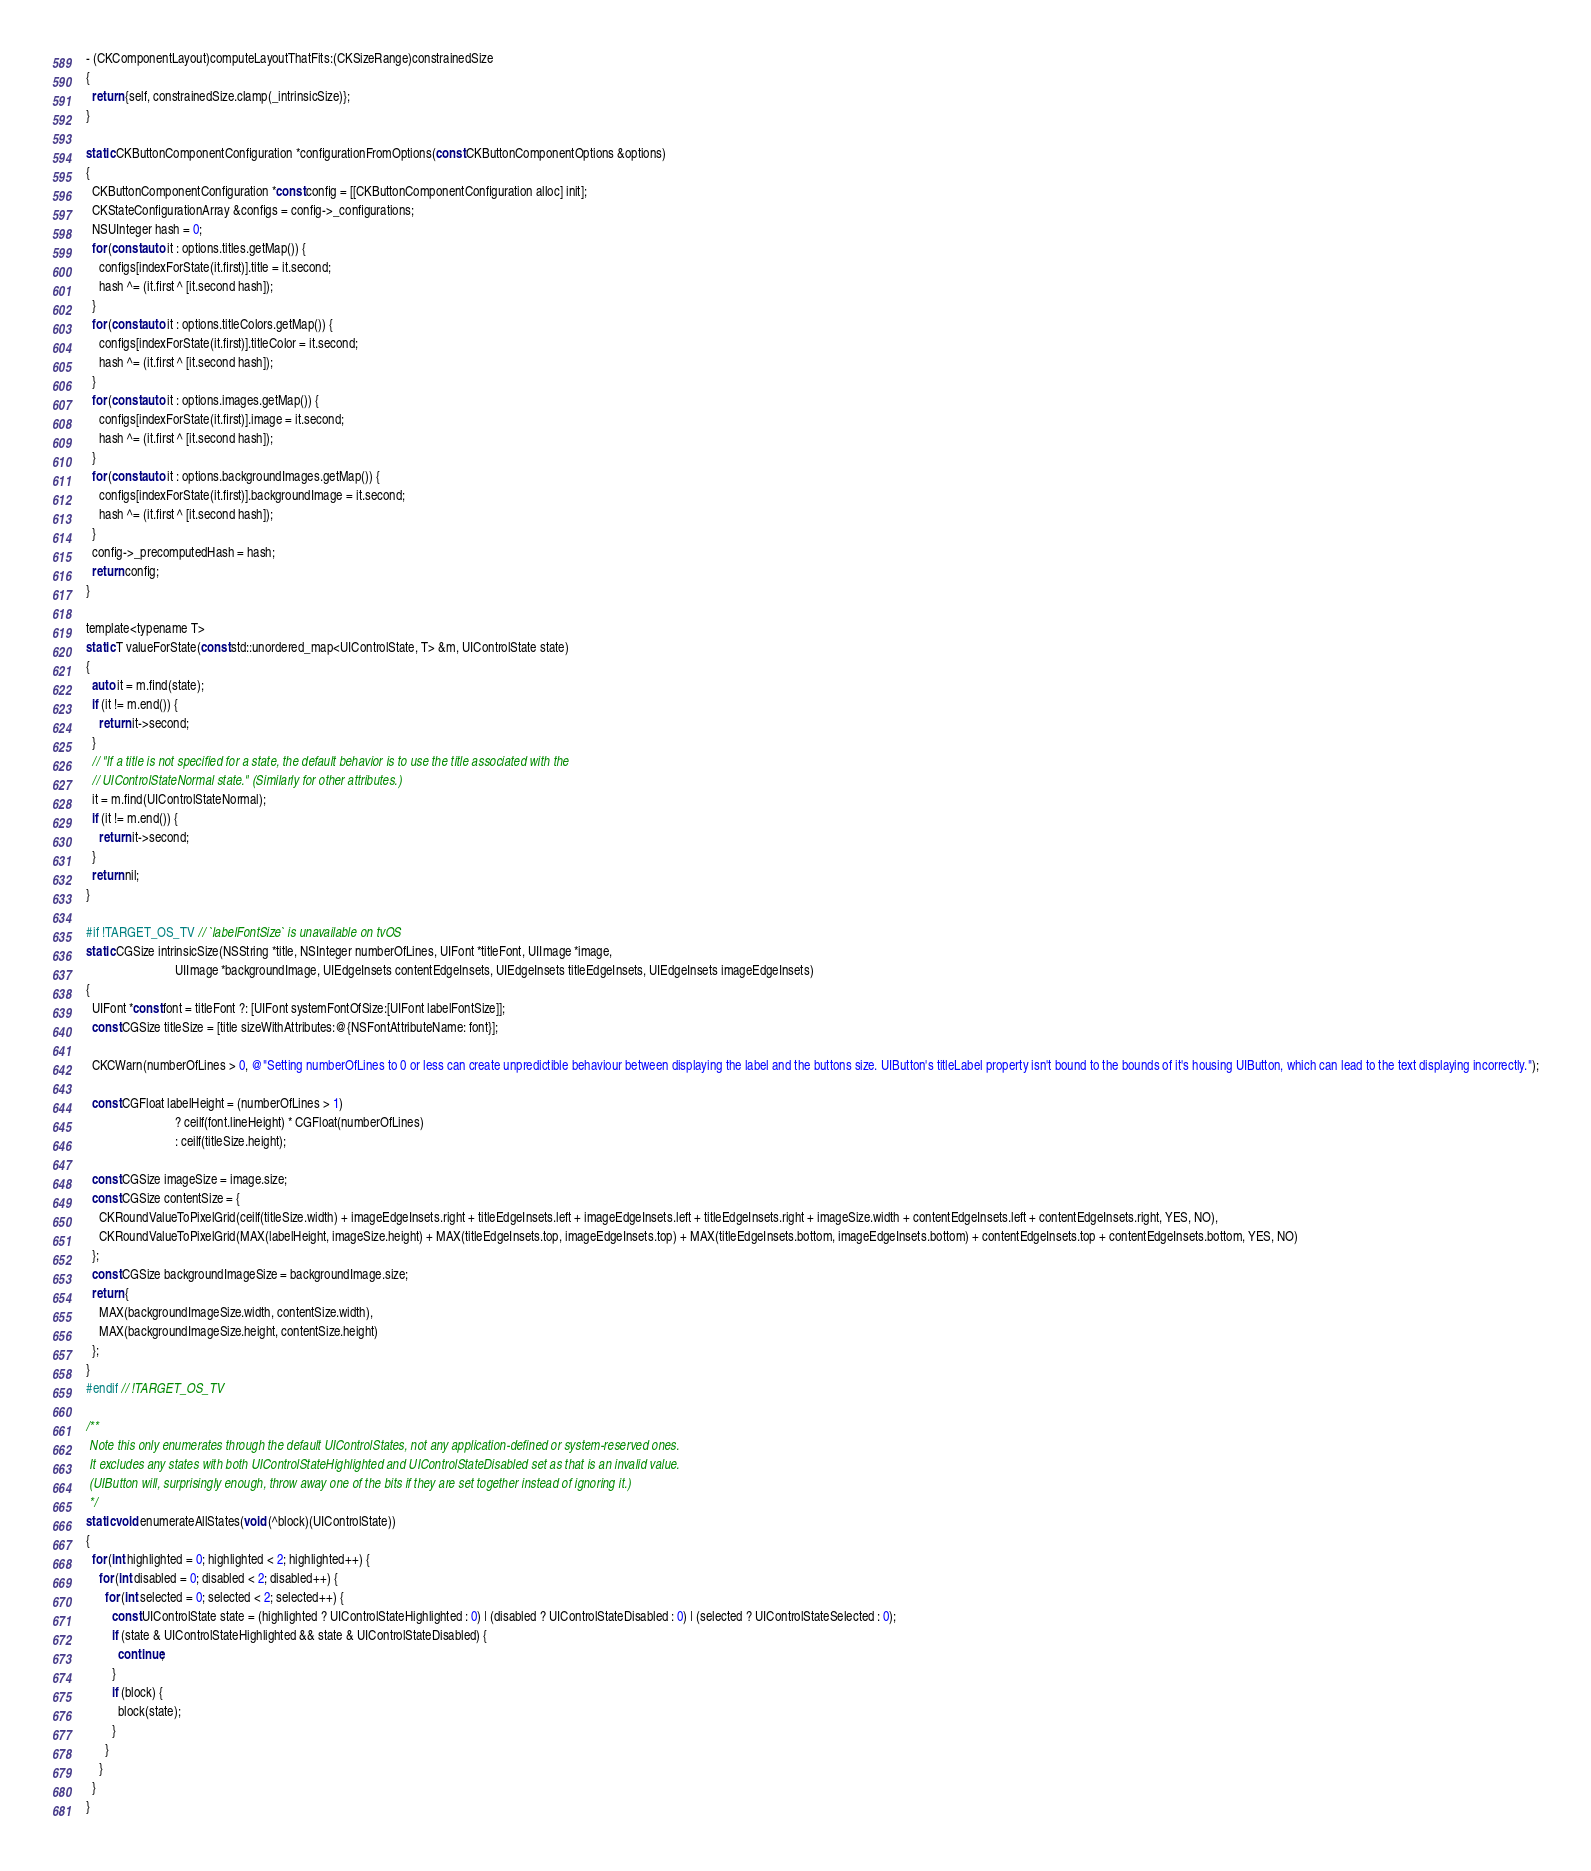Convert code to text. <code><loc_0><loc_0><loc_500><loc_500><_ObjectiveC_>- (CKComponentLayout)computeLayoutThatFits:(CKSizeRange)constrainedSize
{
  return {self, constrainedSize.clamp(_intrinsicSize)};
}

static CKButtonComponentConfiguration *configurationFromOptions(const CKButtonComponentOptions &options)
{
  CKButtonComponentConfiguration *const config = [[CKButtonComponentConfiguration alloc] init];
  CKStateConfigurationArray &configs = config->_configurations;
  NSUInteger hash = 0;
  for (const auto it : options.titles.getMap()) {
    configs[indexForState(it.first)].title = it.second;
    hash ^= (it.first ^ [it.second hash]);
  }
  for (const auto it : options.titleColors.getMap()) {
    configs[indexForState(it.first)].titleColor = it.second;
    hash ^= (it.first ^ [it.second hash]);
  }
  for (const auto it : options.images.getMap()) {
    configs[indexForState(it.first)].image = it.second;
    hash ^= (it.first ^ [it.second hash]);
  }
  for (const auto it : options.backgroundImages.getMap()) {
    configs[indexForState(it.first)].backgroundImage = it.second;
    hash ^= (it.first ^ [it.second hash]);
  }
  config->_precomputedHash = hash;
  return config;
}

template<typename T>
static T valueForState(const std::unordered_map<UIControlState, T> &m, UIControlState state)
{
  auto it = m.find(state);
  if (it != m.end()) {
    return it->second;
  }
  // "If a title is not specified for a state, the default behavior is to use the title associated with the
  // UIControlStateNormal state." (Similarly for other attributes.)
  it = m.find(UIControlStateNormal);
  if (it != m.end()) {
    return it->second;
  }
  return nil;
}

#if !TARGET_OS_TV // `labelFontSize` is unavailable on tvOS
static CGSize intrinsicSize(NSString *title, NSInteger numberOfLines, UIFont *titleFont, UIImage *image,
                            UIImage *backgroundImage, UIEdgeInsets contentEdgeInsets, UIEdgeInsets titleEdgeInsets, UIEdgeInsets imageEdgeInsets)
{
  UIFont *const font = titleFont ?: [UIFont systemFontOfSize:[UIFont labelFontSize]];
  const CGSize titleSize = [title sizeWithAttributes:@{NSFontAttributeName: font}];

  CKCWarn(numberOfLines > 0, @"Setting numberOfLines to 0 or less can create unpredictible behaviour between displaying the label and the buttons size. UIButton's titleLabel property isn't bound to the bounds of it's housing UIButton, which can lead to the text displaying incorrectly.");

  const CGFloat labelHeight = (numberOfLines > 1)
                            ? ceilf(font.lineHeight) * CGFloat(numberOfLines)
                            : ceilf(titleSize.height);

  const CGSize imageSize = image.size;
  const CGSize contentSize = {
    CKRoundValueToPixelGrid(ceilf(titleSize.width) + imageEdgeInsets.right + titleEdgeInsets.left + imageEdgeInsets.left + titleEdgeInsets.right + imageSize.width + contentEdgeInsets.left + contentEdgeInsets.right, YES, NO),
    CKRoundValueToPixelGrid(MAX(labelHeight, imageSize.height) + MAX(titleEdgeInsets.top, imageEdgeInsets.top) + MAX(titleEdgeInsets.bottom, imageEdgeInsets.bottom) + contentEdgeInsets.top + contentEdgeInsets.bottom, YES, NO)
  };
  const CGSize backgroundImageSize = backgroundImage.size;
  return {
    MAX(backgroundImageSize.width, contentSize.width),
    MAX(backgroundImageSize.height, contentSize.height)
  };
}
#endif // !TARGET_OS_TV

/**
 Note this only enumerates through the default UIControlStates, not any application-defined or system-reserved ones.
 It excludes any states with both UIControlStateHighlighted and UIControlStateDisabled set as that is an invalid value.
 (UIButton will, surprisingly enough, throw away one of the bits if they are set together instead of ignoring it.)
 */
static void enumerateAllStates(void (^block)(UIControlState))
{
  for (int highlighted = 0; highlighted < 2; highlighted++) {
    for (int disabled = 0; disabled < 2; disabled++) {
      for (int selected = 0; selected < 2; selected++) {
        const UIControlState state = (highlighted ? UIControlStateHighlighted : 0) | (disabled ? UIControlStateDisabled : 0) | (selected ? UIControlStateSelected : 0);
        if (state & UIControlStateHighlighted && state & UIControlStateDisabled) {
          continue;
        }
        if (block) {
          block(state);
        }
      }
    }
  }
}
</code> 